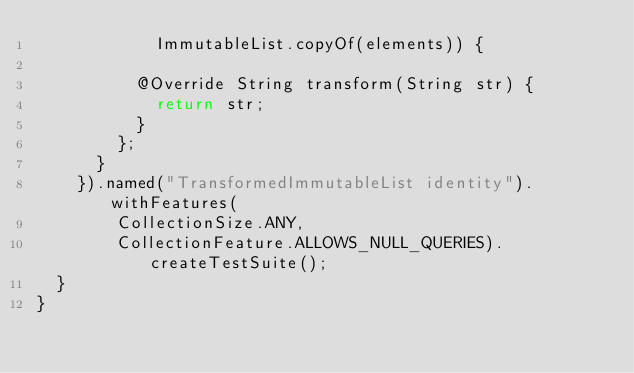Convert code to text. <code><loc_0><loc_0><loc_500><loc_500><_Java_>            ImmutableList.copyOf(elements)) {

          @Override String transform(String str) {
            return str;
          }
        };
      }
    }).named("TransformedImmutableList identity").withFeatures(
        CollectionSize.ANY,
        CollectionFeature.ALLOWS_NULL_QUERIES).createTestSuite();
  }
}
</code> 